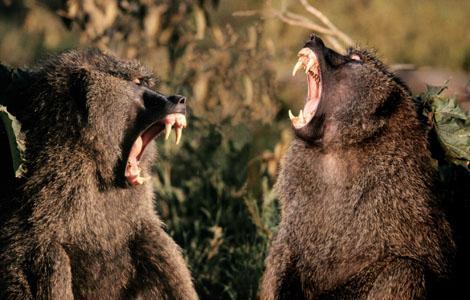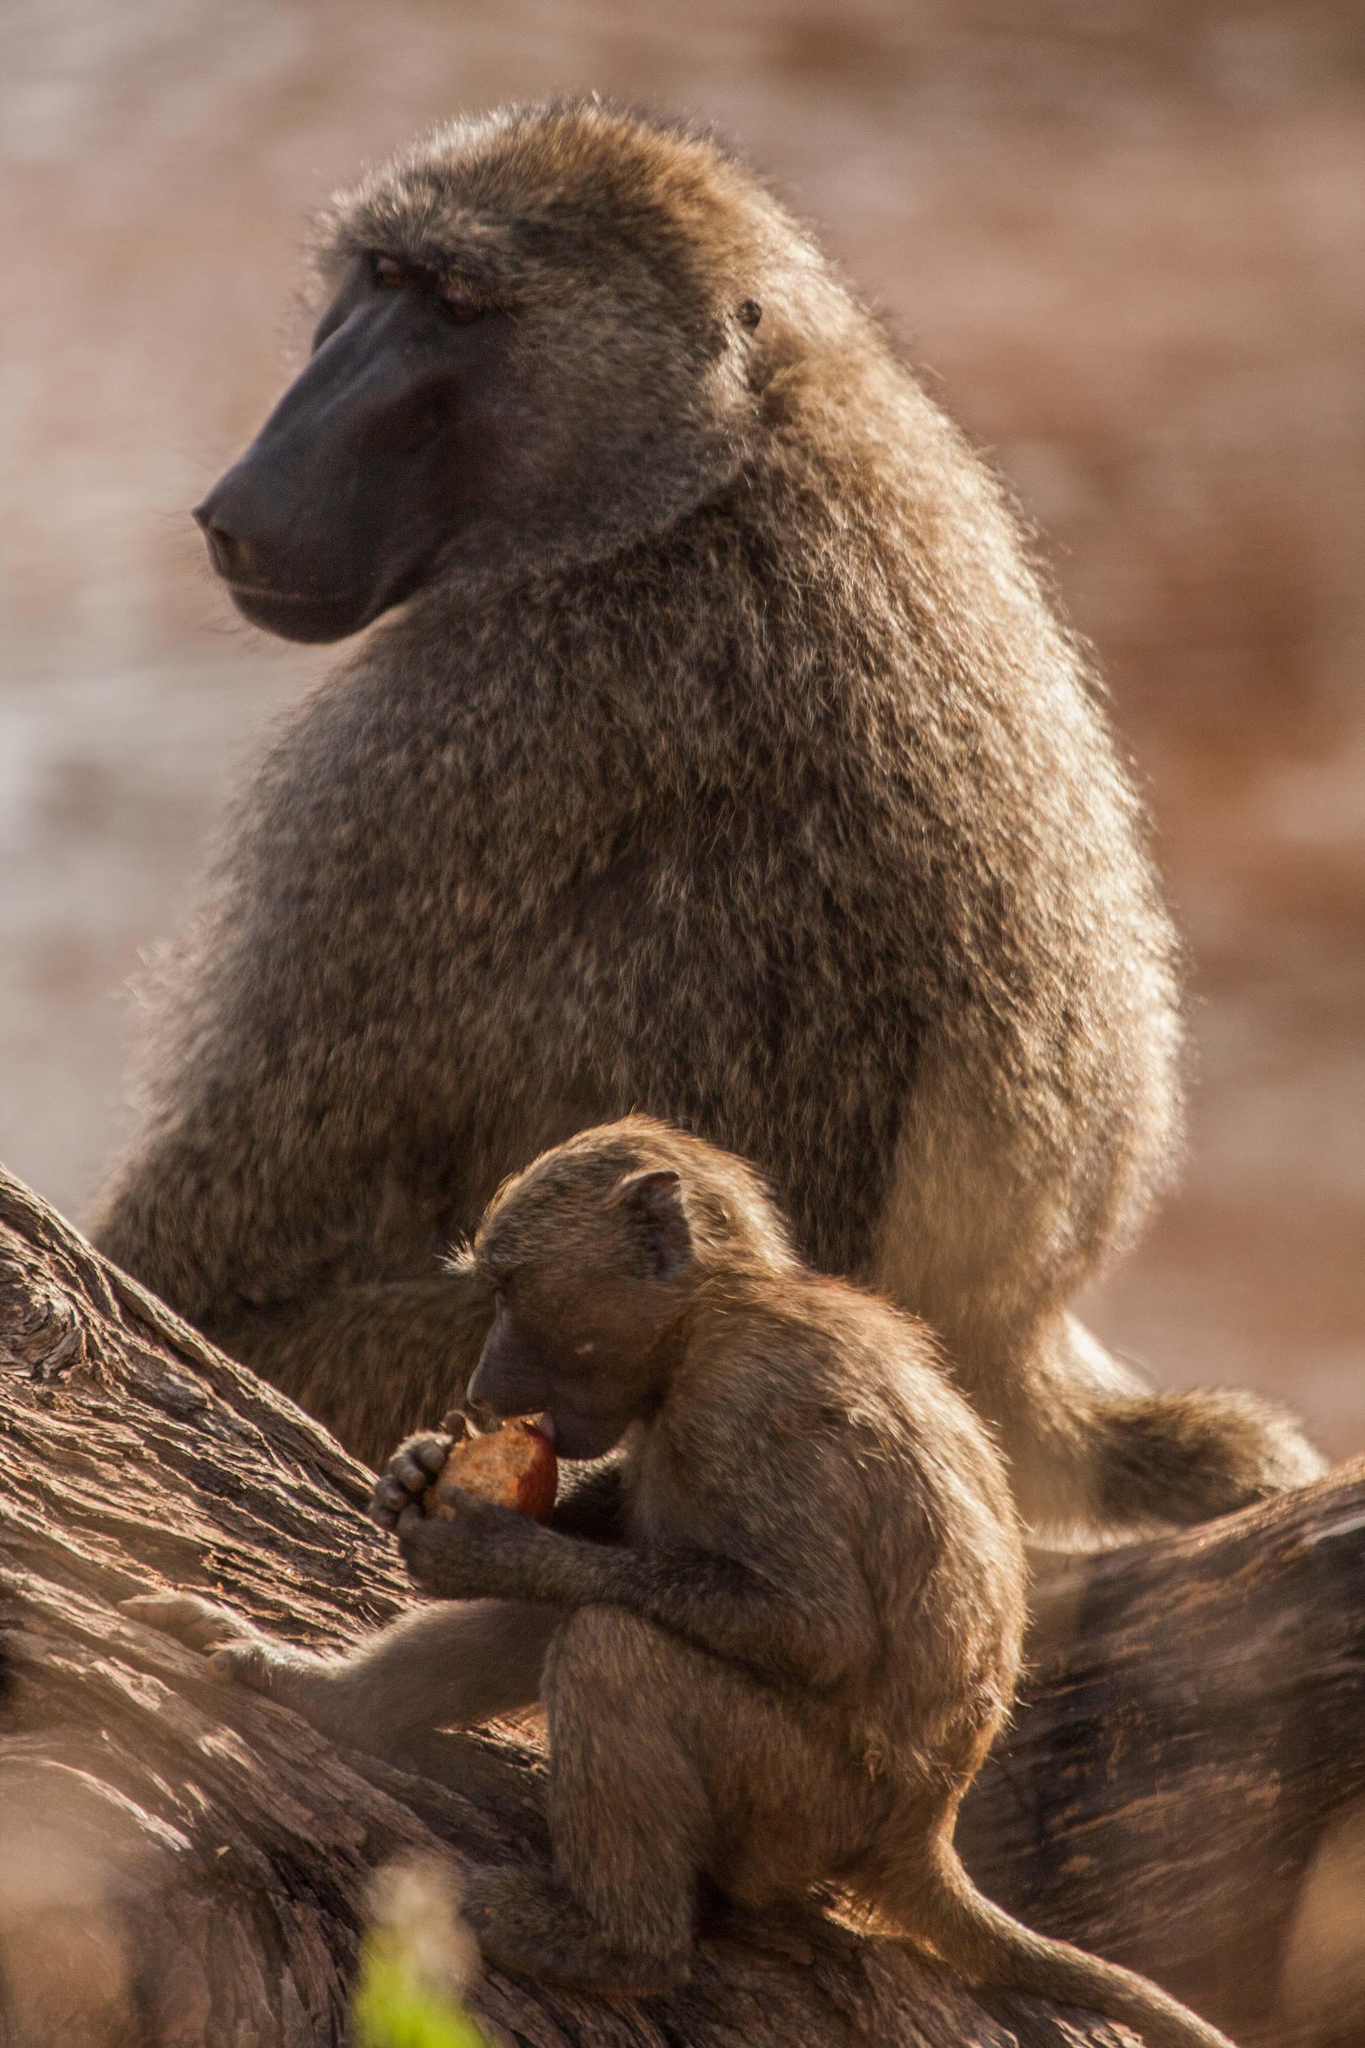The first image is the image on the left, the second image is the image on the right. Assess this claim about the two images: "At least one monkey has its mouth wide open with sharp teeth visible.". Correct or not? Answer yes or no. Yes. The first image is the image on the left, the second image is the image on the right. Examine the images to the left and right. Is the description "An image includes a baboon baring its fangs with wide-opened mouth." accurate? Answer yes or no. Yes. 